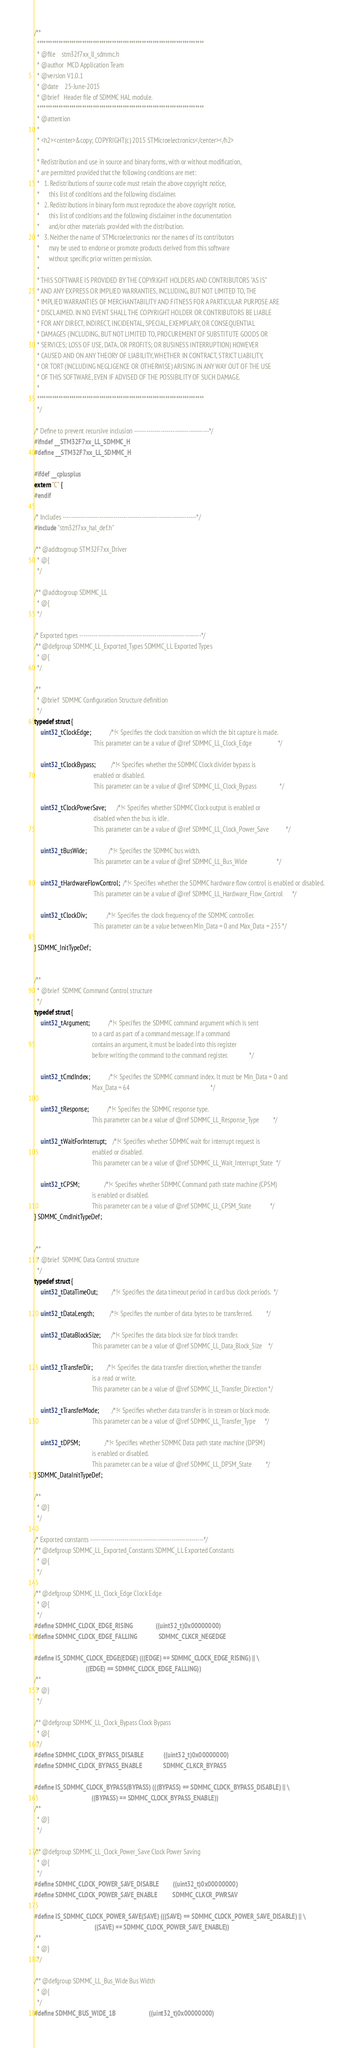<code> <loc_0><loc_0><loc_500><loc_500><_C_>/**
  ******************************************************************************
  * @file    stm32f7xx_ll_sdmmc.h
  * @author  MCD Application Team
  * @version V1.0.1
  * @date    25-June-2015
  * @brief   Header file of SDMMC HAL module.
  ******************************************************************************
  * @attention
  *
  * <h2><center>&copy; COPYRIGHT(c) 2015 STMicroelectronics</center></h2>
  *
  * Redistribution and use in source and binary forms, with or without modification,
  * are permitted provided that the following conditions are met:
  *   1. Redistributions of source code must retain the above copyright notice,
  *      this list of conditions and the following disclaimer.
  *   2. Redistributions in binary form must reproduce the above copyright notice,
  *      this list of conditions and the following disclaimer in the documentation
  *      and/or other materials provided with the distribution.
  *   3. Neither the name of STMicroelectronics nor the names of its contributors
  *      may be used to endorse or promote products derived from this software
  *      without specific prior written permission.
  *
  * THIS SOFTWARE IS PROVIDED BY THE COPYRIGHT HOLDERS AND CONTRIBUTORS "AS IS"
  * AND ANY EXPRESS OR IMPLIED WARRANTIES, INCLUDING, BUT NOT LIMITED TO, THE
  * IMPLIED WARRANTIES OF MERCHANTABILITY AND FITNESS FOR A PARTICULAR PURPOSE ARE
  * DISCLAIMED. IN NO EVENT SHALL THE COPYRIGHT HOLDER OR CONTRIBUTORS BE LIABLE
  * FOR ANY DIRECT, INDIRECT, INCIDENTAL, SPECIAL, EXEMPLARY, OR CONSEQUENTIAL
  * DAMAGES (INCLUDING, BUT NOT LIMITED TO, PROCUREMENT OF SUBSTITUTE GOODS OR
  * SERVICES; LOSS OF USE, DATA, OR PROFITS; OR BUSINESS INTERRUPTION) HOWEVER
  * CAUSED AND ON ANY THEORY OF LIABILITY, WHETHER IN CONTRACT, STRICT LIABILITY,
  * OR TORT (INCLUDING NEGLIGENCE OR OTHERWISE) ARISING IN ANY WAY OUT OF THE USE
  * OF THIS SOFTWARE, EVEN IF ADVISED OF THE POSSIBILITY OF SUCH DAMAGE.
  *
  ******************************************************************************
  */

/* Define to prevent recursive inclusion -------------------------------------*/
#ifndef __STM32F7xx_LL_SDMMC_H
#define __STM32F7xx_LL_SDMMC_H

#ifdef __cplusplus
extern "C" {
#endif

/* Includes ------------------------------------------------------------------*/
#include "stm32f7xx_hal_def.h"

/** @addtogroup STM32F7xx_Driver
  * @{
  */

/** @addtogroup SDMMC_LL
  * @{
  */

/* Exported types ------------------------------------------------------------*/
/** @defgroup SDMMC_LL_Exported_Types SDMMC_LL Exported Types
  * @{
  */

/**
  * @brief  SDMMC Configuration Structure definition
  */
typedef struct {
    uint32_t ClockEdge;            /*!< Specifies the clock transition on which the bit capture is made.
                                      This parameter can be a value of @ref SDMMC_LL_Clock_Edge                 */

    uint32_t ClockBypass;          /*!< Specifies whether the SDMMC Clock divider bypass is
                                      enabled or disabled.
                                      This parameter can be a value of @ref SDMMC_LL_Clock_Bypass               */

    uint32_t ClockPowerSave;       /*!< Specifies whether SDMMC Clock output is enabled or
                                      disabled when the bus is idle.
                                      This parameter can be a value of @ref SDMMC_LL_Clock_Power_Save           */

    uint32_t BusWide;              /*!< Specifies the SDMMC bus width.
                                      This parameter can be a value of @ref SDMMC_LL_Bus_Wide                   */

    uint32_t HardwareFlowControl;  /*!< Specifies whether the SDMMC hardware flow control is enabled or disabled.
                                      This parameter can be a value of @ref SDMMC_LL_Hardware_Flow_Control      */

    uint32_t ClockDiv;             /*!< Specifies the clock frequency of the SDMMC controller.
                                      This parameter can be a value between Min_Data = 0 and Max_Data = 255 */

} SDMMC_InitTypeDef;


/**
  * @brief  SDMMC Command Control structure
  */
typedef struct {
    uint32_t Argument;            /*!< Specifies the SDMMC command argument which is sent
                                     to a card as part of a command message. If a command
                                     contains an argument, it must be loaded into this register
                                     before writing the command to the command register.              */

    uint32_t CmdIndex;            /*!< Specifies the SDMMC command index. It must be Min_Data = 0 and
                                     Max_Data = 64                                                    */

    uint32_t Response;            /*!< Specifies the SDMMC response type.
                                     This parameter can be a value of @ref SDMMC_LL_Response_Type         */

    uint32_t WaitForInterrupt;    /*!< Specifies whether SDMMC wait for interrupt request is
                                     enabled or disabled.
                                     This parameter can be a value of @ref SDMMC_LL_Wait_Interrupt_State  */

    uint32_t CPSM;                /*!< Specifies whether SDMMC Command path state machine (CPSM)
                                     is enabled or disabled.
                                     This parameter can be a value of @ref SDMMC_LL_CPSM_State            */
} SDMMC_CmdInitTypeDef;


/**
  * @brief  SDMMC Data Control structure
  */
typedef struct {
    uint32_t DataTimeOut;         /*!< Specifies the data timeout period in card bus clock periods.  */

    uint32_t DataLength;          /*!< Specifies the number of data bytes to be transferred.         */

    uint32_t DataBlockSize;       /*!< Specifies the data block size for block transfer.
                                     This parameter can be a value of @ref SDMMC_LL_Data_Block_Size    */

    uint32_t TransferDir;         /*!< Specifies the data transfer direction, whether the transfer
                                     is a read or write.
                                     This parameter can be a value of @ref SDMMC_LL_Transfer_Direction */

    uint32_t TransferMode;        /*!< Specifies whether data transfer is in stream or block mode.
                                     This parameter can be a value of @ref SDMMC_LL_Transfer_Type      */

    uint32_t DPSM;                /*!< Specifies whether SDMMC Data path state machine (DPSM)
                                     is enabled or disabled.
                                     This parameter can be a value of @ref SDMMC_LL_DPSM_State         */
} SDMMC_DataInitTypeDef;

/**
  * @}
  */

/* Exported constants --------------------------------------------------------*/
/** @defgroup SDMMC_LL_Exported_Constants SDMMC_LL Exported Constants
  * @{
  */

/** @defgroup SDMMC_LL_Clock_Edge Clock Edge
  * @{
  */
#define SDMMC_CLOCK_EDGE_RISING               ((uint32_t)0x00000000)
#define SDMMC_CLOCK_EDGE_FALLING              SDMMC_CLKCR_NEGEDGE

#define IS_SDMMC_CLOCK_EDGE(EDGE) (((EDGE) == SDMMC_CLOCK_EDGE_RISING) || \
                                  ((EDGE) == SDMMC_CLOCK_EDGE_FALLING))
/**
  * @}
  */

/** @defgroup SDMMC_LL_Clock_Bypass Clock Bypass
  * @{
  */
#define SDMMC_CLOCK_BYPASS_DISABLE             ((uint32_t)0x00000000)
#define SDMMC_CLOCK_BYPASS_ENABLE              SDMMC_CLKCR_BYPASS

#define IS_SDMMC_CLOCK_BYPASS(BYPASS) (((BYPASS) == SDMMC_CLOCK_BYPASS_DISABLE) || \
                                      ((BYPASS) == SDMMC_CLOCK_BYPASS_ENABLE))
/**
  * @}
  */

/** @defgroup SDMMC_LL_Clock_Power_Save Clock Power Saving
  * @{
  */
#define SDMMC_CLOCK_POWER_SAVE_DISABLE         ((uint32_t)0x00000000)
#define SDMMC_CLOCK_POWER_SAVE_ENABLE          SDMMC_CLKCR_PWRSAV

#define IS_SDMMC_CLOCK_POWER_SAVE(SAVE) (((SAVE) == SDMMC_CLOCK_POWER_SAVE_DISABLE) || \
                                        ((SAVE) == SDMMC_CLOCK_POWER_SAVE_ENABLE))
/**
  * @}
  */

/** @defgroup SDMMC_LL_Bus_Wide Bus Width
  * @{
  */
#define SDMMC_BUS_WIDE_1B                      ((uint32_t)0x00000000)</code> 